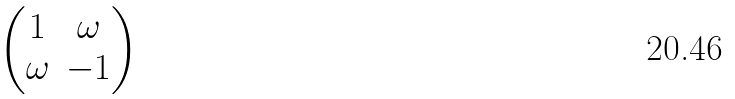<formula> <loc_0><loc_0><loc_500><loc_500>\begin{pmatrix} 1 & \omega \\ \omega & - 1 \end{pmatrix}</formula> 